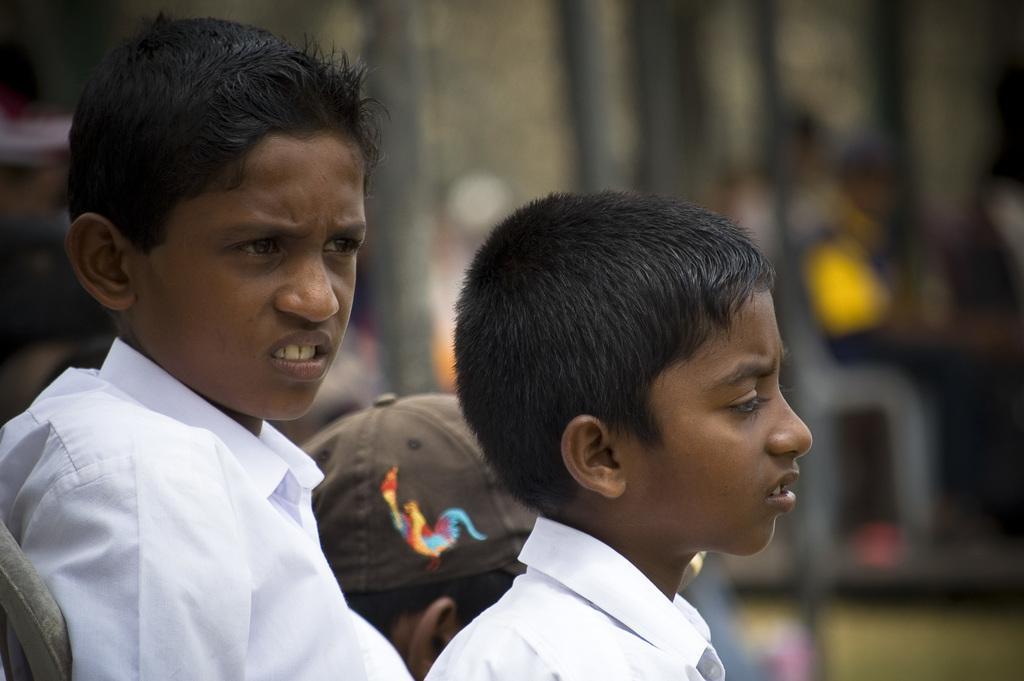In one or two sentences, can you explain what this image depicts? In this image in the foreground there are two boys visible in the middle of them there is a person wearing a cap, background is blurry. 